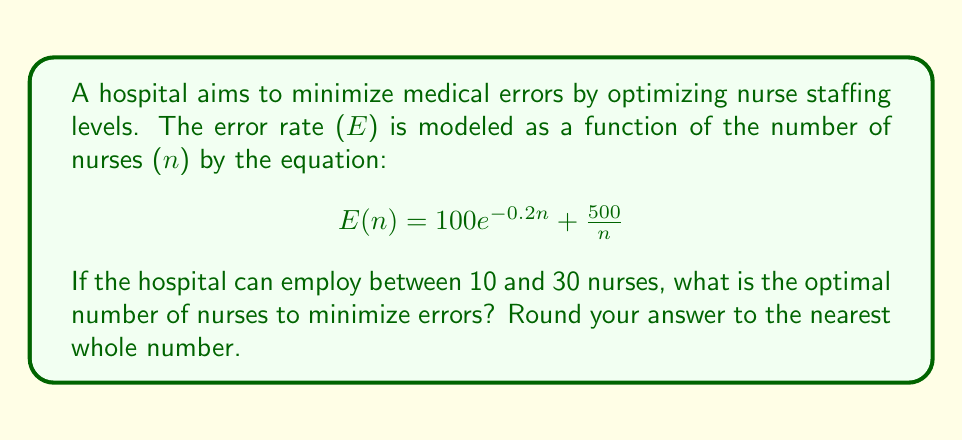Can you solve this math problem? To find the optimal number of nurses, we need to minimize the error function E(n) subject to the constraints 10 ≤ n ≤ 30.

1) First, we find the critical points by taking the derivative of E(n) and setting it equal to zero:

   $$ E'(n) = -20e^{-0.2n} - \frac{500}{n^2} = 0 $$

2) Solving this equation analytically is difficult, so we'll use numerical methods. We can use a computer or graphing calculator to plot E(n) for 10 ≤ n ≤ 30.

3) Alternatively, we can evaluate E(n) at several points within the range:

   For n = 10: E(10) ≈ 82.0
   For n = 15: E(15) ≈ 54.7
   For n = 20: E(20) ≈ 45.0
   For n = 25: E(25) ≈ 41.9
   For n = 30: E(30) ≈ 42.2

4) From these values, we can see that the minimum occurs near n = 25.

5) To refine our answer, we can evaluate E(n) for values around 25:

   E(24) ≈ 42.1
   E(25) ≈ 41.9
   E(26) ≈ 41.9

6) The minimum error occurs at n = 25 or 26. Since we need to round to the nearest whole number, either value is acceptable.
Answer: 25 nurses 